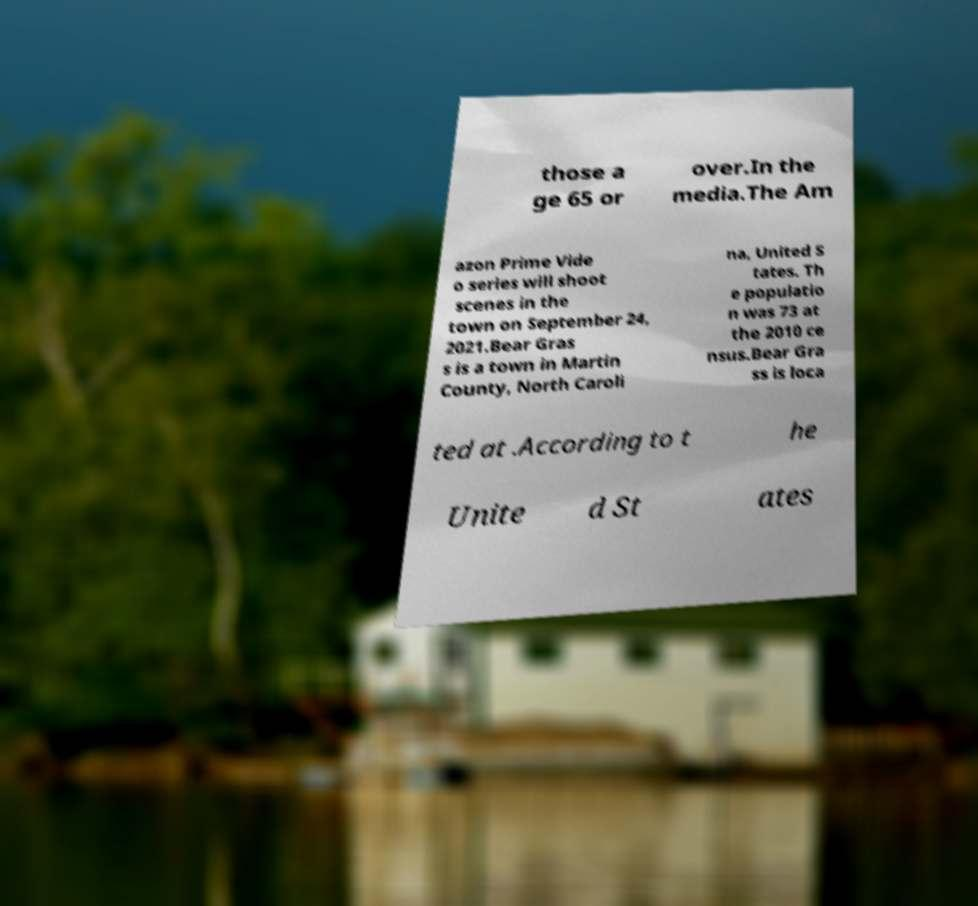Please read and relay the text visible in this image. What does it say? those a ge 65 or over.In the media.The Am azon Prime Vide o series will shoot scenes in the town on September 24, 2021.Bear Gras s is a town in Martin County, North Caroli na, United S tates. Th e populatio n was 73 at the 2010 ce nsus.Bear Gra ss is loca ted at .According to t he Unite d St ates 